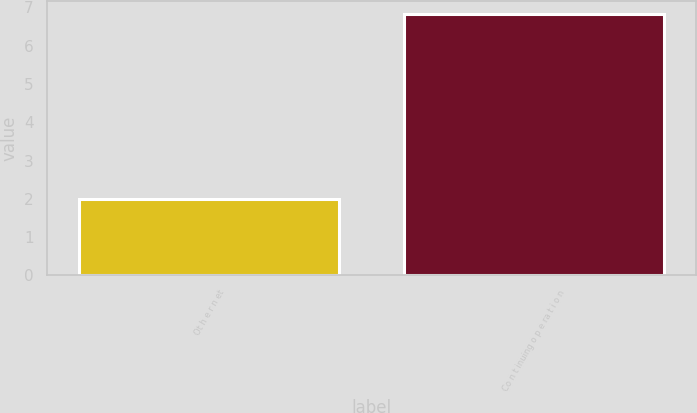Convert chart. <chart><loc_0><loc_0><loc_500><loc_500><bar_chart><fcel>Ot h e r n et<fcel>Co n t inuing o p e ra t i o n<nl><fcel>2<fcel>6.82<nl></chart> 